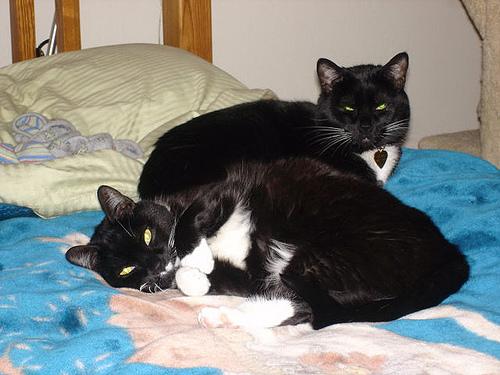Which color are the sheets?
Concise answer only. Blue. What kind of furniture are the cats on?
Write a very short answer. Bed. Are the cats the same color?
Write a very short answer. Yes. 